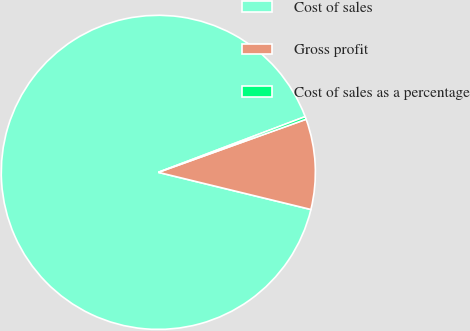Convert chart to OTSL. <chart><loc_0><loc_0><loc_500><loc_500><pie_chart><fcel>Cost of sales<fcel>Gross profit<fcel>Cost of sales as a percentage<nl><fcel>90.42%<fcel>9.29%<fcel>0.28%<nl></chart> 